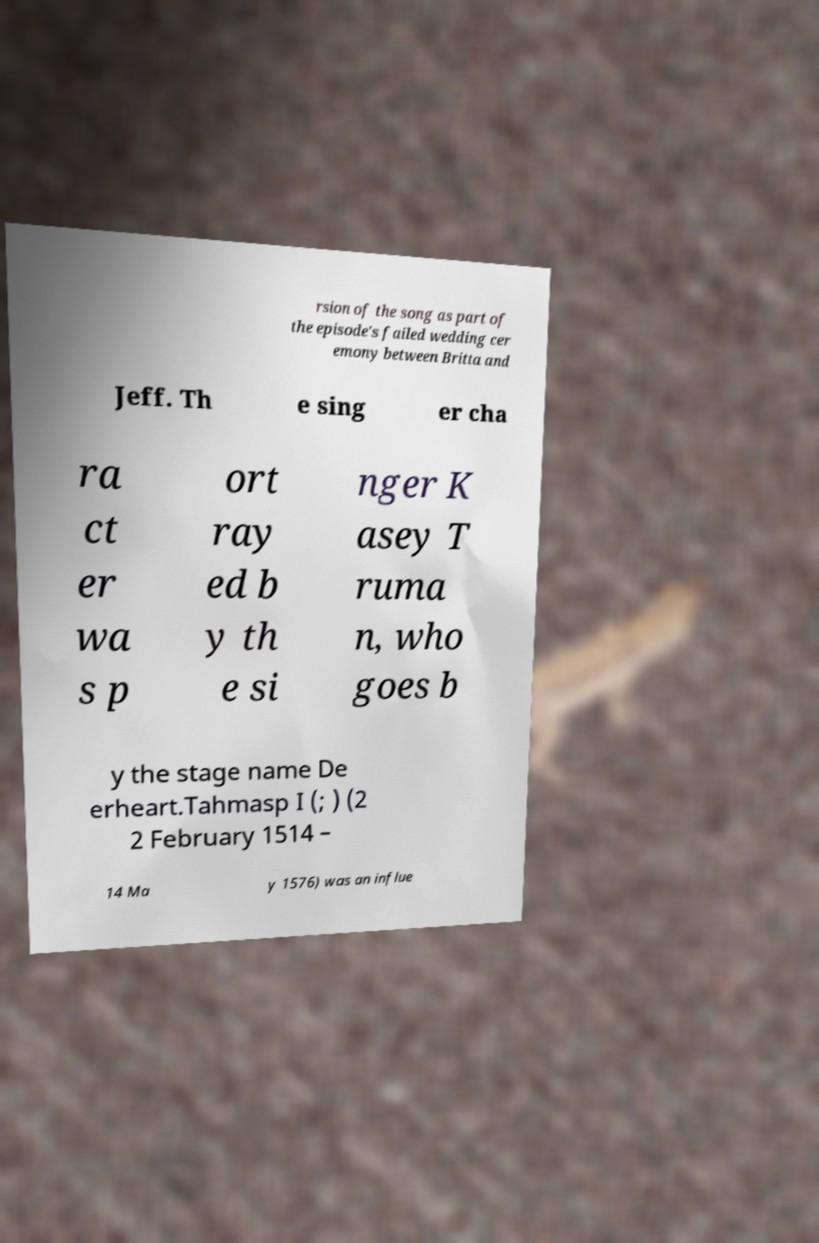Please identify and transcribe the text found in this image. rsion of the song as part of the episode's failed wedding cer emony between Britta and Jeff. Th e sing er cha ra ct er wa s p ort ray ed b y th e si nger K asey T ruma n, who goes b y the stage name De erheart.Tahmasp I (; ) (2 2 February 1514 – 14 Ma y 1576) was an influe 